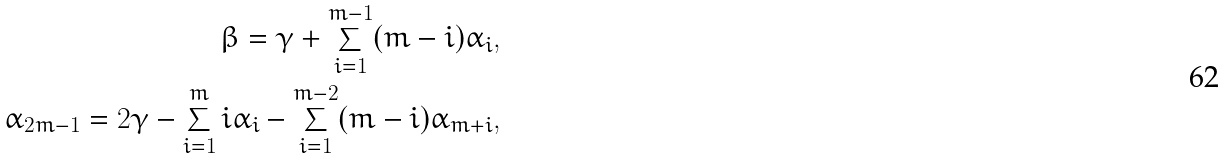<formula> <loc_0><loc_0><loc_500><loc_500>\beta = \gamma + \sum _ { i = 1 } ^ { m - 1 } ( m - i ) \alpha _ { i } , \\ \alpha _ { 2 m - 1 } = 2 \gamma - \sum _ { i = 1 } ^ { m } i \alpha _ { i } - \sum _ { i = 1 } ^ { m - 2 } ( m - i ) \alpha _ { m + i } ,</formula> 